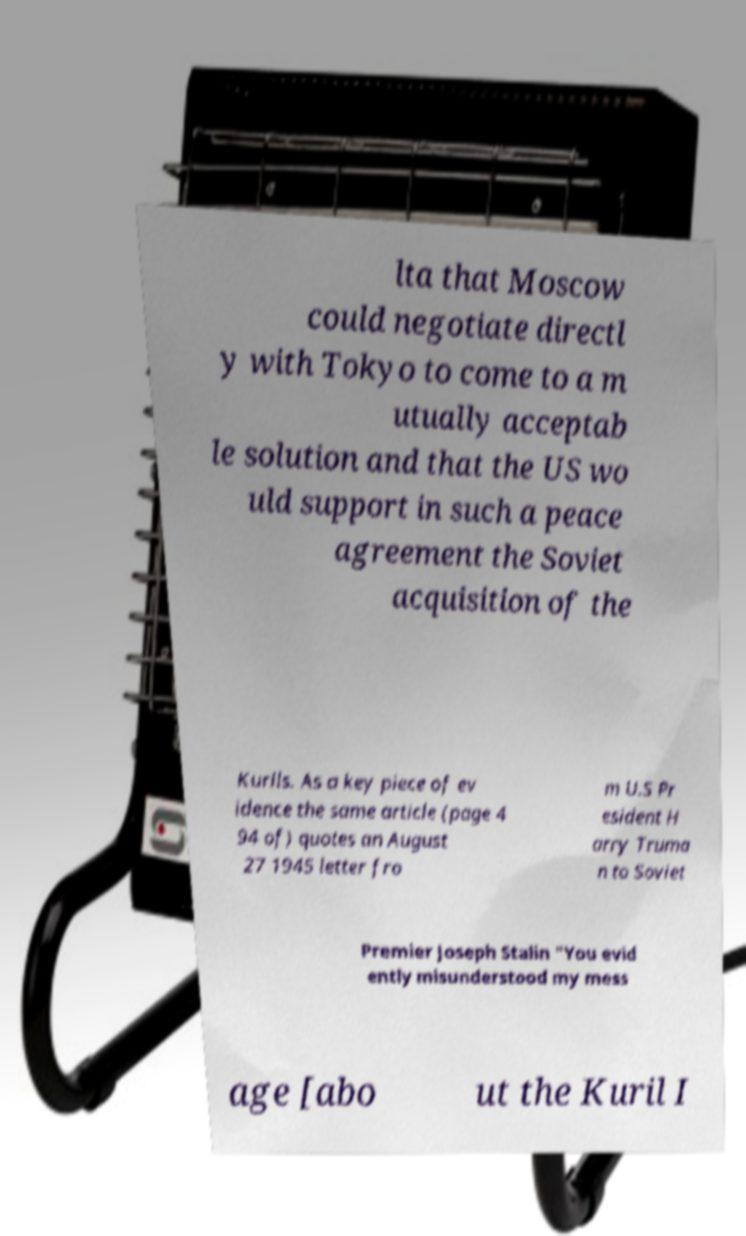Could you extract and type out the text from this image? lta that Moscow could negotiate directl y with Tokyo to come to a m utually acceptab le solution and that the US wo uld support in such a peace agreement the Soviet acquisition of the Kurils. As a key piece of ev idence the same article (page 4 94 of) quotes an August 27 1945 letter fro m U.S Pr esident H arry Truma n to Soviet Premier Joseph Stalin "You evid ently misunderstood my mess age [abo ut the Kuril I 